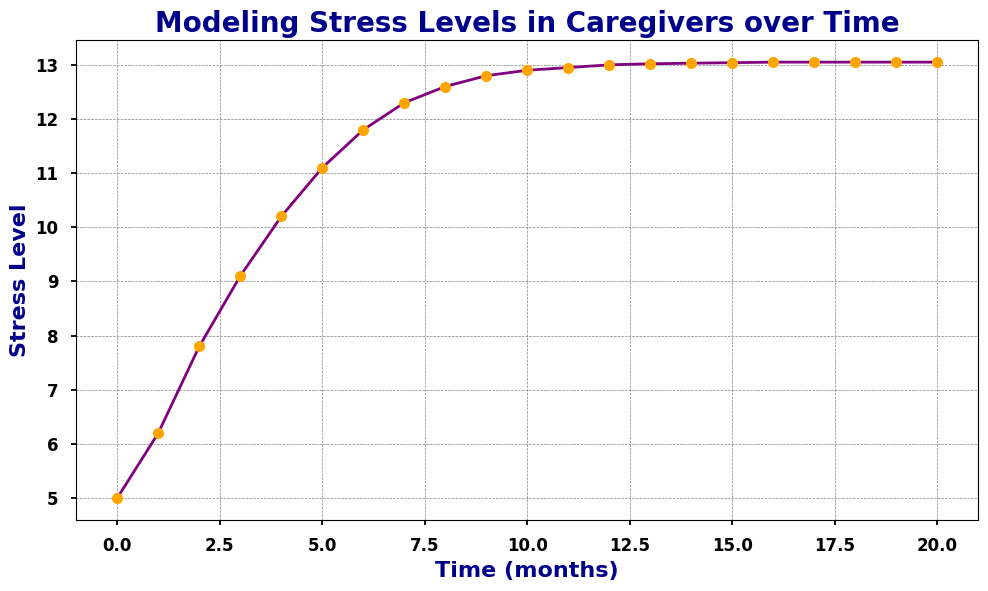What is the stress level at time 5 months? At time 5 months, find the corresponding y-value from the plot, which shows the stress level.
Answer: 11.1 When does the stress level first reach or exceed 12? Look at the x-axis and find the point where the y-value (stress level) first hits or goes above 12. This occurs between time 7 and 8 months.
Answer: 7 months Compare the stress levels at time 3 months and time 10 months. Which one is higher? Check the y-values for the points at x=3 and x=10. Stress level at time 3 months is around 9.1, and at time 10 months, it is around 12.9. Therefore, the stress level at time 10 months is higher.
Answer: Stress level at 10 months How many months does it take for the stress level to stabilize around 13? Find the point on the x-axis where the y-values start to consistently approximate 13. This occurs around time 12 months.
Answer: 12 months What colors are used for the plot line and the markers? Observe the visual attributes of the plot. The line color is purple and the markers are orange.
Answer: Purple for line, Orange for markers What is the overall trend of the stress levels from 0 to 20 months? Assess the plot from left to right. Initially, the stress level rises steeply and then levels off, showing a logistic growth pattern where increasing gradually slows and stabilizes.
Answer: Increases, then stabilizes At which time intervals does the stress level show the most rapid increase? Identify the sections of the plot where the y-value changes most steeply. This happens significantly from 1 month to around 5 months.
Answer: 1 to 5 months What is the general shape of the stress level curve over time? Analyze the overall shape of the plot, which starts with a steep increase and gradually flattens out, resembling an S-curve typical of logistic growth.
Answer: Logistic (S-curve) What is the difference in stress levels between time 4 months and time 10 months? Find the y-values for time 4 months (around 10.2) and time 10 months (around 12.9), then calculate the difference: 12.9 - 10.2 = 2.7.
Answer: 2.7 What happens to the stress level after 15 months? Observe the trend of the y-values after the point at 15 months. The values remain almost constant, indicating that the stress level has stabilized around 13.05.
Answer: Stabilizes around 13.05 